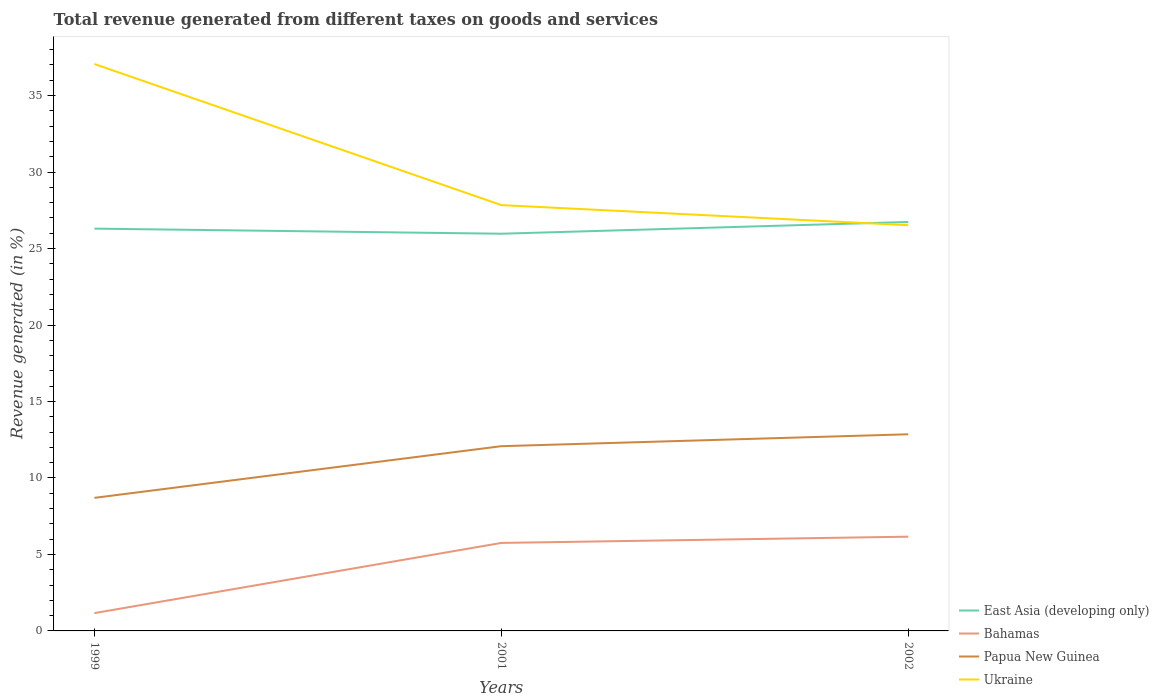Does the line corresponding to East Asia (developing only) intersect with the line corresponding to Bahamas?
Offer a very short reply. No. Is the number of lines equal to the number of legend labels?
Provide a short and direct response. Yes. Across all years, what is the maximum total revenue generated in Papua New Guinea?
Ensure brevity in your answer.  8.7. In which year was the total revenue generated in Bahamas maximum?
Provide a succinct answer. 1999. What is the total total revenue generated in East Asia (developing only) in the graph?
Provide a short and direct response. -0.44. What is the difference between the highest and the second highest total revenue generated in Papua New Guinea?
Ensure brevity in your answer.  4.16. What is the difference between the highest and the lowest total revenue generated in Bahamas?
Provide a succinct answer. 2. Is the total revenue generated in Bahamas strictly greater than the total revenue generated in Ukraine over the years?
Ensure brevity in your answer.  Yes. What is the difference between two consecutive major ticks on the Y-axis?
Ensure brevity in your answer.  5. Does the graph contain any zero values?
Give a very brief answer. No. Does the graph contain grids?
Your answer should be very brief. No. What is the title of the graph?
Give a very brief answer. Total revenue generated from different taxes on goods and services. What is the label or title of the Y-axis?
Make the answer very short. Revenue generated (in %). What is the Revenue generated (in %) of East Asia (developing only) in 1999?
Your response must be concise. 26.3. What is the Revenue generated (in %) of Bahamas in 1999?
Provide a succinct answer. 1.16. What is the Revenue generated (in %) of Papua New Guinea in 1999?
Provide a succinct answer. 8.7. What is the Revenue generated (in %) in Ukraine in 1999?
Provide a short and direct response. 37.06. What is the Revenue generated (in %) of East Asia (developing only) in 2001?
Keep it short and to the point. 25.97. What is the Revenue generated (in %) of Bahamas in 2001?
Make the answer very short. 5.75. What is the Revenue generated (in %) in Papua New Guinea in 2001?
Ensure brevity in your answer.  12.08. What is the Revenue generated (in %) of Ukraine in 2001?
Give a very brief answer. 27.84. What is the Revenue generated (in %) of East Asia (developing only) in 2002?
Your answer should be very brief. 26.74. What is the Revenue generated (in %) in Bahamas in 2002?
Your answer should be very brief. 6.16. What is the Revenue generated (in %) in Papua New Guinea in 2002?
Provide a short and direct response. 12.86. What is the Revenue generated (in %) in Ukraine in 2002?
Provide a succinct answer. 26.53. Across all years, what is the maximum Revenue generated (in %) in East Asia (developing only)?
Make the answer very short. 26.74. Across all years, what is the maximum Revenue generated (in %) in Bahamas?
Your response must be concise. 6.16. Across all years, what is the maximum Revenue generated (in %) in Papua New Guinea?
Offer a terse response. 12.86. Across all years, what is the maximum Revenue generated (in %) in Ukraine?
Ensure brevity in your answer.  37.06. Across all years, what is the minimum Revenue generated (in %) of East Asia (developing only)?
Your answer should be very brief. 25.97. Across all years, what is the minimum Revenue generated (in %) of Bahamas?
Make the answer very short. 1.16. Across all years, what is the minimum Revenue generated (in %) of Papua New Guinea?
Offer a very short reply. 8.7. Across all years, what is the minimum Revenue generated (in %) in Ukraine?
Make the answer very short. 26.53. What is the total Revenue generated (in %) of East Asia (developing only) in the graph?
Offer a very short reply. 79.01. What is the total Revenue generated (in %) in Bahamas in the graph?
Ensure brevity in your answer.  13.08. What is the total Revenue generated (in %) in Papua New Guinea in the graph?
Give a very brief answer. 33.63. What is the total Revenue generated (in %) of Ukraine in the graph?
Ensure brevity in your answer.  91.43. What is the difference between the Revenue generated (in %) of East Asia (developing only) in 1999 and that in 2001?
Offer a terse response. 0.33. What is the difference between the Revenue generated (in %) in Bahamas in 1999 and that in 2001?
Your answer should be very brief. -4.59. What is the difference between the Revenue generated (in %) in Papua New Guinea in 1999 and that in 2001?
Give a very brief answer. -3.38. What is the difference between the Revenue generated (in %) of Ukraine in 1999 and that in 2001?
Offer a terse response. 9.22. What is the difference between the Revenue generated (in %) of East Asia (developing only) in 1999 and that in 2002?
Give a very brief answer. -0.44. What is the difference between the Revenue generated (in %) in Bahamas in 1999 and that in 2002?
Make the answer very short. -5. What is the difference between the Revenue generated (in %) in Papua New Guinea in 1999 and that in 2002?
Ensure brevity in your answer.  -4.16. What is the difference between the Revenue generated (in %) of Ukraine in 1999 and that in 2002?
Your answer should be very brief. 10.54. What is the difference between the Revenue generated (in %) in East Asia (developing only) in 2001 and that in 2002?
Keep it short and to the point. -0.77. What is the difference between the Revenue generated (in %) of Bahamas in 2001 and that in 2002?
Your answer should be very brief. -0.41. What is the difference between the Revenue generated (in %) of Papua New Guinea in 2001 and that in 2002?
Your answer should be very brief. -0.78. What is the difference between the Revenue generated (in %) in Ukraine in 2001 and that in 2002?
Offer a terse response. 1.31. What is the difference between the Revenue generated (in %) in East Asia (developing only) in 1999 and the Revenue generated (in %) in Bahamas in 2001?
Keep it short and to the point. 20.55. What is the difference between the Revenue generated (in %) in East Asia (developing only) in 1999 and the Revenue generated (in %) in Papua New Guinea in 2001?
Your answer should be compact. 14.22. What is the difference between the Revenue generated (in %) of East Asia (developing only) in 1999 and the Revenue generated (in %) of Ukraine in 2001?
Offer a terse response. -1.54. What is the difference between the Revenue generated (in %) of Bahamas in 1999 and the Revenue generated (in %) of Papua New Guinea in 2001?
Offer a very short reply. -10.91. What is the difference between the Revenue generated (in %) in Bahamas in 1999 and the Revenue generated (in %) in Ukraine in 2001?
Your answer should be compact. -26.68. What is the difference between the Revenue generated (in %) of Papua New Guinea in 1999 and the Revenue generated (in %) of Ukraine in 2001?
Provide a short and direct response. -19.14. What is the difference between the Revenue generated (in %) in East Asia (developing only) in 1999 and the Revenue generated (in %) in Bahamas in 2002?
Make the answer very short. 20.14. What is the difference between the Revenue generated (in %) in East Asia (developing only) in 1999 and the Revenue generated (in %) in Papua New Guinea in 2002?
Your answer should be compact. 13.45. What is the difference between the Revenue generated (in %) of East Asia (developing only) in 1999 and the Revenue generated (in %) of Ukraine in 2002?
Your response must be concise. -0.22. What is the difference between the Revenue generated (in %) in Bahamas in 1999 and the Revenue generated (in %) in Papua New Guinea in 2002?
Provide a succinct answer. -11.69. What is the difference between the Revenue generated (in %) in Bahamas in 1999 and the Revenue generated (in %) in Ukraine in 2002?
Offer a terse response. -25.36. What is the difference between the Revenue generated (in %) in Papua New Guinea in 1999 and the Revenue generated (in %) in Ukraine in 2002?
Offer a terse response. -17.83. What is the difference between the Revenue generated (in %) of East Asia (developing only) in 2001 and the Revenue generated (in %) of Bahamas in 2002?
Your answer should be very brief. 19.81. What is the difference between the Revenue generated (in %) in East Asia (developing only) in 2001 and the Revenue generated (in %) in Papua New Guinea in 2002?
Offer a very short reply. 13.11. What is the difference between the Revenue generated (in %) in East Asia (developing only) in 2001 and the Revenue generated (in %) in Ukraine in 2002?
Make the answer very short. -0.56. What is the difference between the Revenue generated (in %) of Bahamas in 2001 and the Revenue generated (in %) of Papua New Guinea in 2002?
Ensure brevity in your answer.  -7.1. What is the difference between the Revenue generated (in %) in Bahamas in 2001 and the Revenue generated (in %) in Ukraine in 2002?
Your response must be concise. -20.77. What is the difference between the Revenue generated (in %) in Papua New Guinea in 2001 and the Revenue generated (in %) in Ukraine in 2002?
Offer a very short reply. -14.45. What is the average Revenue generated (in %) in East Asia (developing only) per year?
Provide a succinct answer. 26.34. What is the average Revenue generated (in %) in Bahamas per year?
Provide a succinct answer. 4.36. What is the average Revenue generated (in %) of Papua New Guinea per year?
Make the answer very short. 11.21. What is the average Revenue generated (in %) in Ukraine per year?
Keep it short and to the point. 30.48. In the year 1999, what is the difference between the Revenue generated (in %) in East Asia (developing only) and Revenue generated (in %) in Bahamas?
Offer a terse response. 25.14. In the year 1999, what is the difference between the Revenue generated (in %) of East Asia (developing only) and Revenue generated (in %) of Papua New Guinea?
Provide a succinct answer. 17.6. In the year 1999, what is the difference between the Revenue generated (in %) in East Asia (developing only) and Revenue generated (in %) in Ukraine?
Provide a short and direct response. -10.76. In the year 1999, what is the difference between the Revenue generated (in %) in Bahamas and Revenue generated (in %) in Papua New Guinea?
Your answer should be compact. -7.54. In the year 1999, what is the difference between the Revenue generated (in %) in Bahamas and Revenue generated (in %) in Ukraine?
Give a very brief answer. -35.9. In the year 1999, what is the difference between the Revenue generated (in %) of Papua New Guinea and Revenue generated (in %) of Ukraine?
Your answer should be compact. -28.36. In the year 2001, what is the difference between the Revenue generated (in %) of East Asia (developing only) and Revenue generated (in %) of Bahamas?
Make the answer very short. 20.22. In the year 2001, what is the difference between the Revenue generated (in %) in East Asia (developing only) and Revenue generated (in %) in Papua New Guinea?
Offer a very short reply. 13.89. In the year 2001, what is the difference between the Revenue generated (in %) of East Asia (developing only) and Revenue generated (in %) of Ukraine?
Provide a succinct answer. -1.87. In the year 2001, what is the difference between the Revenue generated (in %) in Bahamas and Revenue generated (in %) in Papua New Guinea?
Ensure brevity in your answer.  -6.32. In the year 2001, what is the difference between the Revenue generated (in %) of Bahamas and Revenue generated (in %) of Ukraine?
Your response must be concise. -22.09. In the year 2001, what is the difference between the Revenue generated (in %) in Papua New Guinea and Revenue generated (in %) in Ukraine?
Offer a terse response. -15.76. In the year 2002, what is the difference between the Revenue generated (in %) in East Asia (developing only) and Revenue generated (in %) in Bahamas?
Offer a very short reply. 20.58. In the year 2002, what is the difference between the Revenue generated (in %) in East Asia (developing only) and Revenue generated (in %) in Papua New Guinea?
Ensure brevity in your answer.  13.88. In the year 2002, what is the difference between the Revenue generated (in %) of East Asia (developing only) and Revenue generated (in %) of Ukraine?
Offer a very short reply. 0.21. In the year 2002, what is the difference between the Revenue generated (in %) of Bahamas and Revenue generated (in %) of Papua New Guinea?
Give a very brief answer. -6.69. In the year 2002, what is the difference between the Revenue generated (in %) of Bahamas and Revenue generated (in %) of Ukraine?
Your answer should be compact. -20.36. In the year 2002, what is the difference between the Revenue generated (in %) in Papua New Guinea and Revenue generated (in %) in Ukraine?
Offer a terse response. -13.67. What is the ratio of the Revenue generated (in %) in East Asia (developing only) in 1999 to that in 2001?
Offer a very short reply. 1.01. What is the ratio of the Revenue generated (in %) of Bahamas in 1999 to that in 2001?
Keep it short and to the point. 0.2. What is the ratio of the Revenue generated (in %) of Papua New Guinea in 1999 to that in 2001?
Your answer should be compact. 0.72. What is the ratio of the Revenue generated (in %) of Ukraine in 1999 to that in 2001?
Give a very brief answer. 1.33. What is the ratio of the Revenue generated (in %) in East Asia (developing only) in 1999 to that in 2002?
Your answer should be compact. 0.98. What is the ratio of the Revenue generated (in %) of Bahamas in 1999 to that in 2002?
Make the answer very short. 0.19. What is the ratio of the Revenue generated (in %) of Papua New Guinea in 1999 to that in 2002?
Ensure brevity in your answer.  0.68. What is the ratio of the Revenue generated (in %) of Ukraine in 1999 to that in 2002?
Keep it short and to the point. 1.4. What is the ratio of the Revenue generated (in %) in East Asia (developing only) in 2001 to that in 2002?
Your answer should be compact. 0.97. What is the ratio of the Revenue generated (in %) of Bahamas in 2001 to that in 2002?
Your answer should be very brief. 0.93. What is the ratio of the Revenue generated (in %) in Papua New Guinea in 2001 to that in 2002?
Offer a very short reply. 0.94. What is the ratio of the Revenue generated (in %) of Ukraine in 2001 to that in 2002?
Offer a terse response. 1.05. What is the difference between the highest and the second highest Revenue generated (in %) of East Asia (developing only)?
Keep it short and to the point. 0.44. What is the difference between the highest and the second highest Revenue generated (in %) of Bahamas?
Your answer should be very brief. 0.41. What is the difference between the highest and the second highest Revenue generated (in %) of Papua New Guinea?
Your answer should be compact. 0.78. What is the difference between the highest and the second highest Revenue generated (in %) of Ukraine?
Provide a succinct answer. 9.22. What is the difference between the highest and the lowest Revenue generated (in %) of East Asia (developing only)?
Your answer should be compact. 0.77. What is the difference between the highest and the lowest Revenue generated (in %) of Bahamas?
Your answer should be very brief. 5. What is the difference between the highest and the lowest Revenue generated (in %) of Papua New Guinea?
Offer a terse response. 4.16. What is the difference between the highest and the lowest Revenue generated (in %) in Ukraine?
Provide a succinct answer. 10.54. 